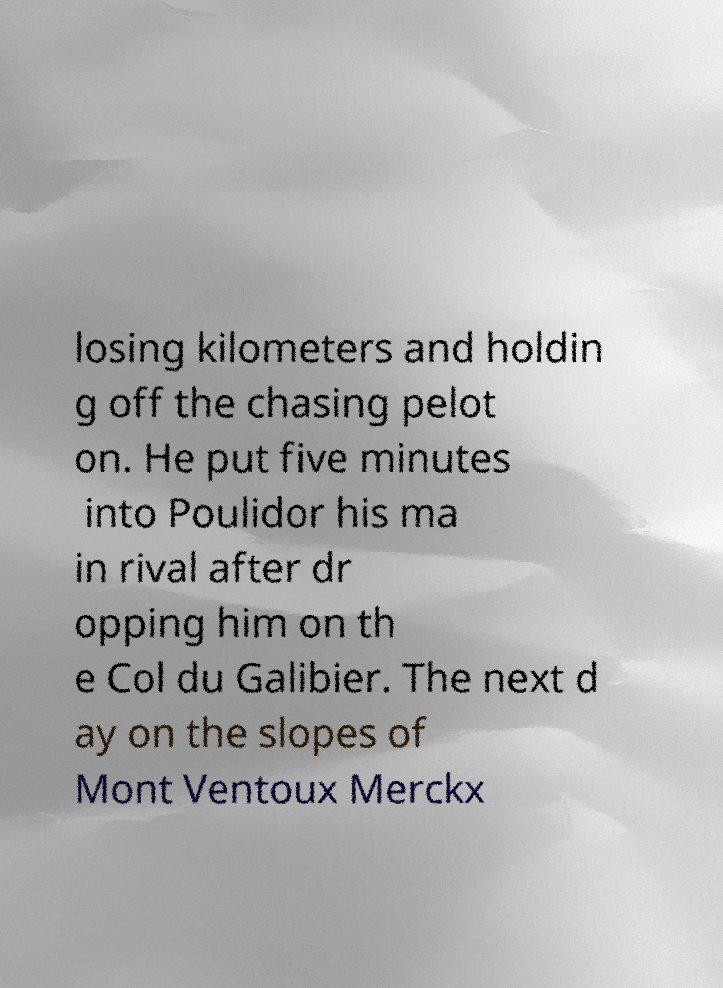Please read and relay the text visible in this image. What does it say? losing kilometers and holdin g off the chasing pelot on. He put five minutes into Poulidor his ma in rival after dr opping him on th e Col du Galibier. The next d ay on the slopes of Mont Ventoux Merckx 